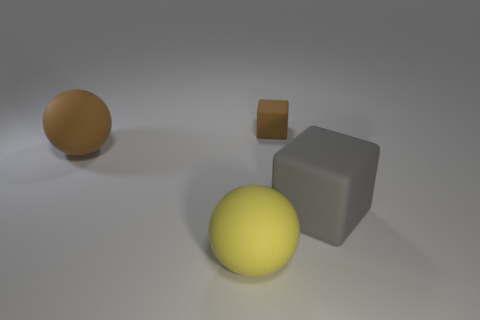Add 4 small rubber objects. How many objects exist? 8 Add 1 tiny green rubber cylinders. How many tiny green rubber cylinders exist? 1 Subtract 0 yellow cylinders. How many objects are left? 4 Subtract all cyan blocks. Subtract all red balls. How many blocks are left? 2 Subtract all large matte objects. Subtract all big brown matte objects. How many objects are left? 0 Add 2 large matte things. How many large matte things are left? 5 